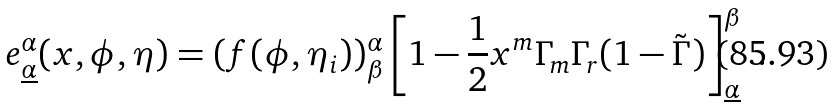<formula> <loc_0><loc_0><loc_500><loc_500>e _ { \underline { \alpha } } ^ { \alpha } ( x , \phi , \eta ) = ( f ( \phi , \eta _ { i } ) ) _ { \beta } ^ { \alpha } \left [ 1 - { \frac { 1 } { 2 } } x ^ { m } \Gamma _ { m } \Gamma _ { r } ( 1 - \tilde { \Gamma } ) \right ] _ { \underline { \alpha } } ^ { \beta } \ .</formula> 